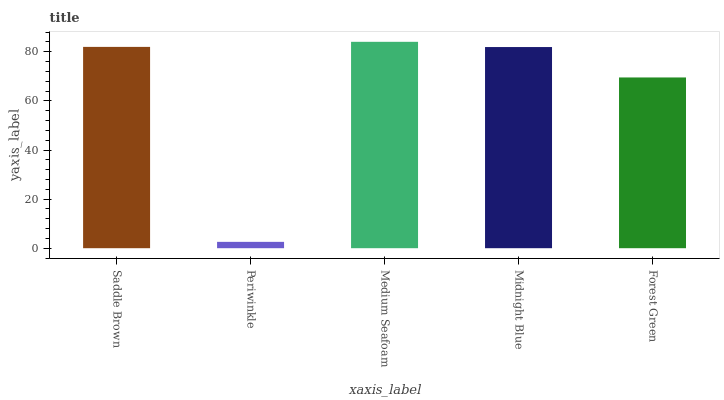Is Periwinkle the minimum?
Answer yes or no. Yes. Is Medium Seafoam the maximum?
Answer yes or no. Yes. Is Medium Seafoam the minimum?
Answer yes or no. No. Is Periwinkle the maximum?
Answer yes or no. No. Is Medium Seafoam greater than Periwinkle?
Answer yes or no. Yes. Is Periwinkle less than Medium Seafoam?
Answer yes or no. Yes. Is Periwinkle greater than Medium Seafoam?
Answer yes or no. No. Is Medium Seafoam less than Periwinkle?
Answer yes or no. No. Is Midnight Blue the high median?
Answer yes or no. Yes. Is Midnight Blue the low median?
Answer yes or no. Yes. Is Periwinkle the high median?
Answer yes or no. No. Is Medium Seafoam the low median?
Answer yes or no. No. 